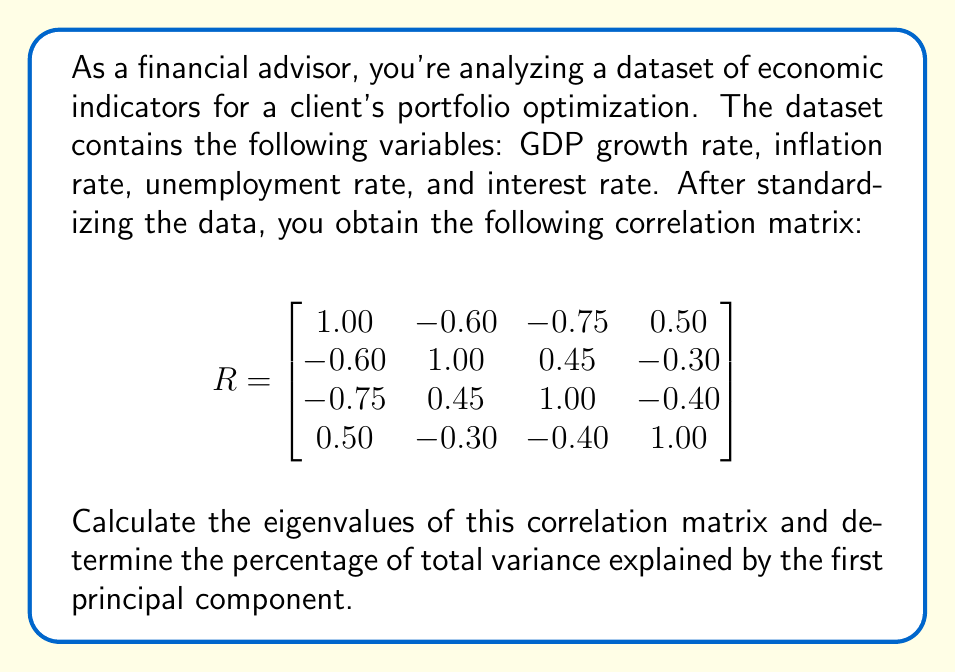Can you solve this math problem? To perform principal component analysis and determine the percentage of total variance explained by the first principal component, we need to follow these steps:

1. Calculate the eigenvalues of the correlation matrix.
2. Order the eigenvalues from largest to smallest.
3. Calculate the total variance (sum of all eigenvalues).
4. Determine the percentage of total variance explained by the first principal component.

Step 1: Calculate the eigenvalues
To find the eigenvalues, we need to solve the characteristic equation:
$$\det(R - \lambda I) = 0$$

Expanding this determinant leads to a 4th-degree polynomial equation. Solving this equation (usually done with software) gives us the following eigenvalues:

$\lambda_1 \approx 2.3954$
$\lambda_2 \approx 0.8546$
$\lambda_3 \approx 0.4835$
$\lambda_4 \approx 0.2665$

Step 2: Order eigenvalues
The eigenvalues are already ordered from largest to smallest.

Step 3: Calculate total variance
The total variance is the sum of all eigenvalues:

$$\text{Total Variance} = \sum_{i=1}^4 \lambda_i = 2.3954 + 0.8546 + 0.4835 + 0.2665 = 4$$

Note that for a correlation matrix, the total variance always equals the number of variables.

Step 4: Percentage of total variance explained by first principal component
The percentage of total variance explained by the first principal component is:

$$\text{Percentage} = \frac{\lambda_1}{\text{Total Variance}} \times 100\% = \frac{2.3954}{4} \times 100\% \approx 59.885\%$$
Answer: The percentage of total variance explained by the first principal component is approximately 59.885%. 